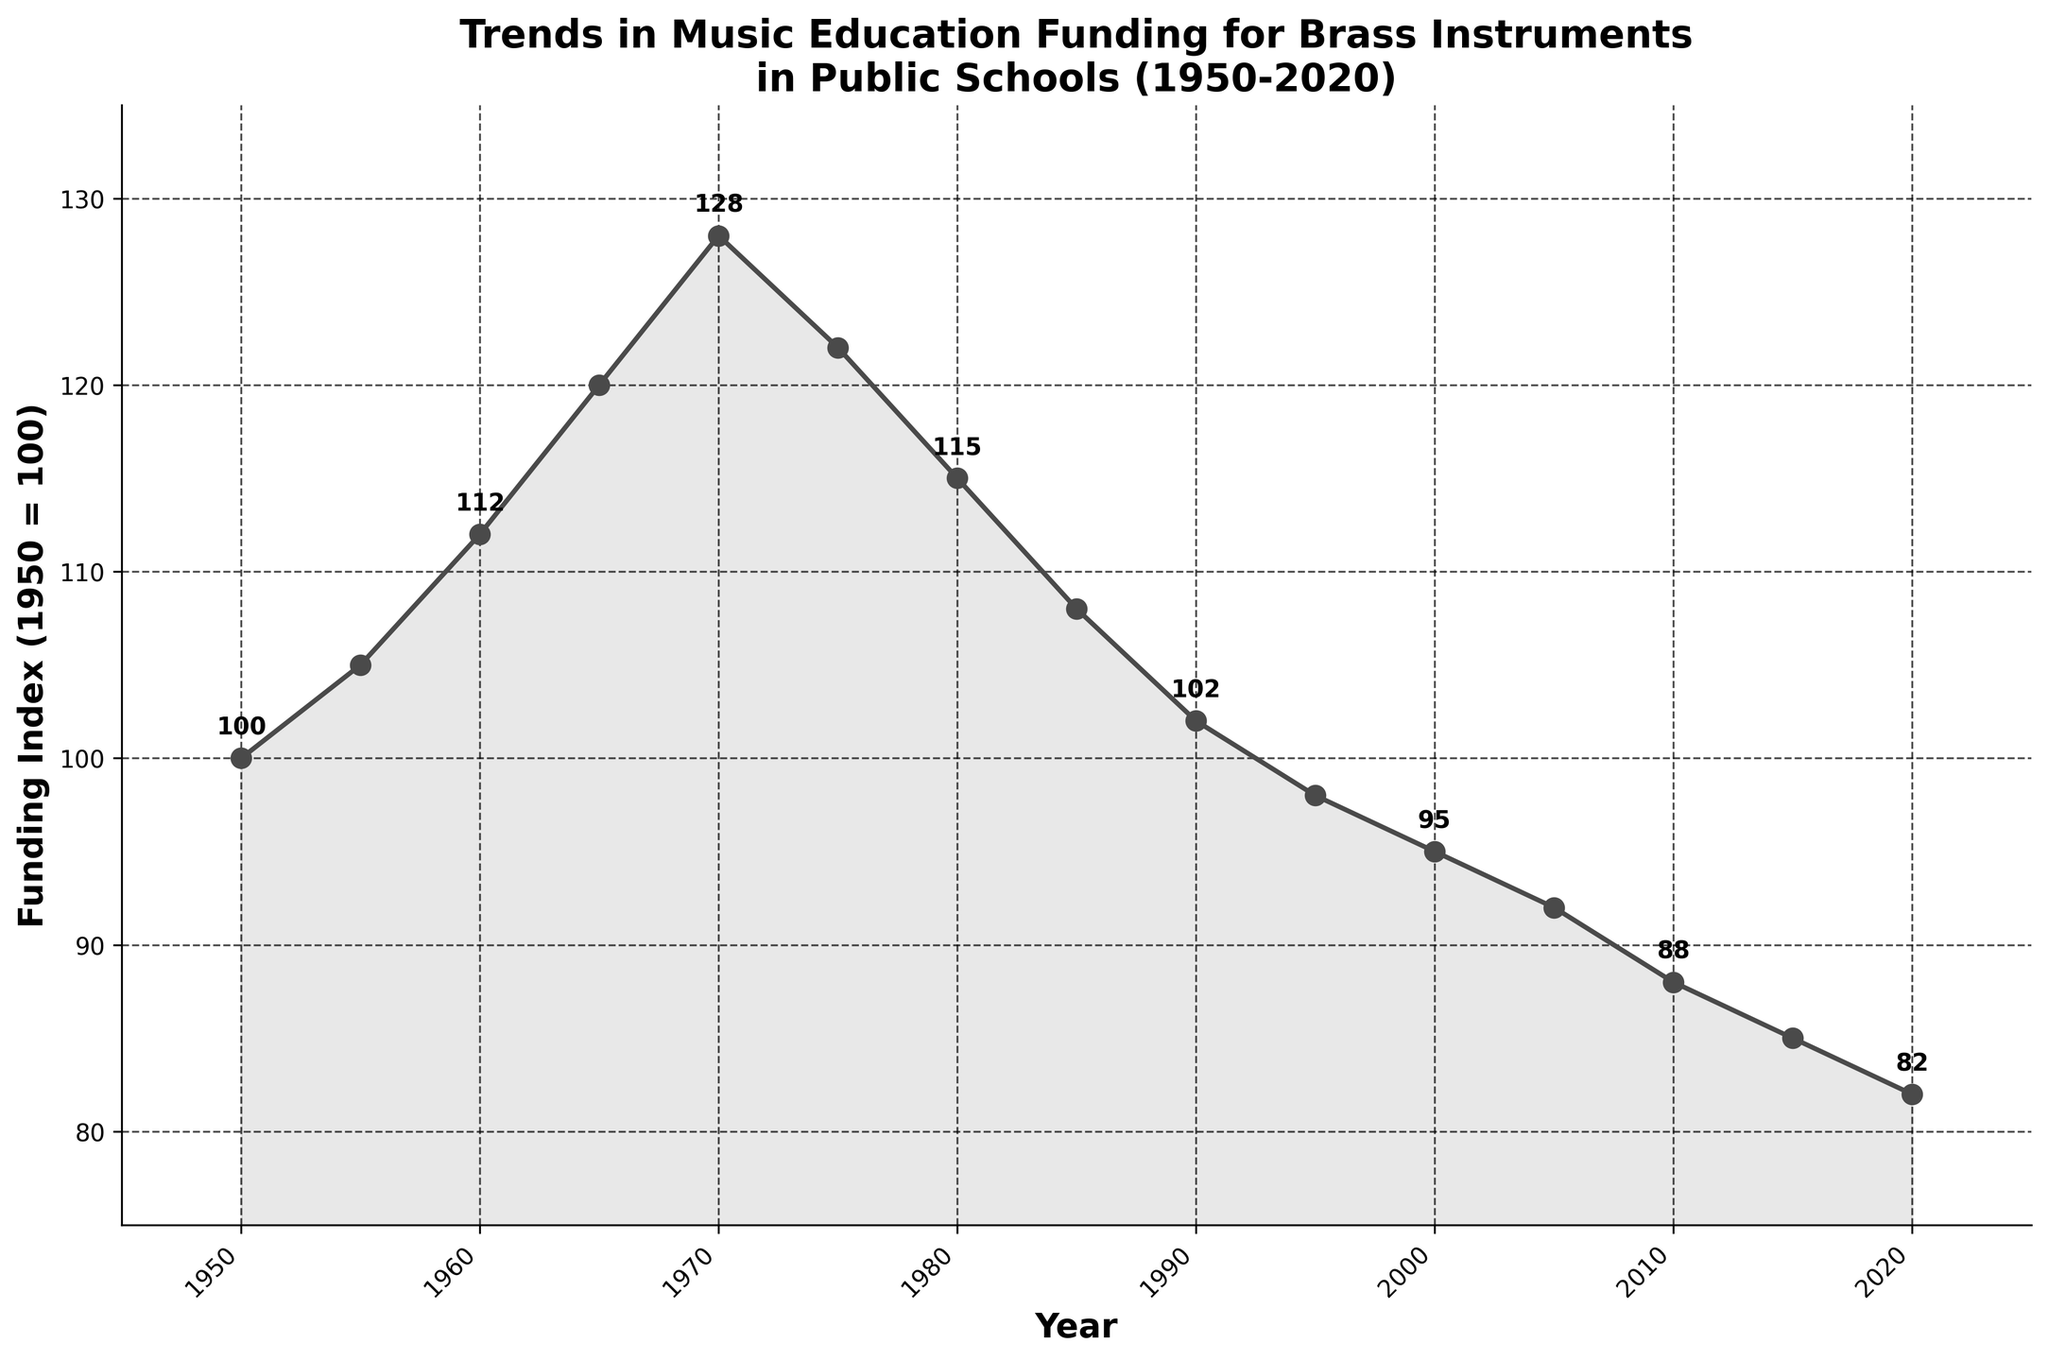What is the Funding Index value in 1970? Refer to the point on the line graph corresponding to the year 1970. The value is marked at 128.
Answer: 128 Which year had the highest Funding Index? Look for the peak of the line on the graph. The highest value is in 1970.
Answer: 1970 What is the range of the Funding Index values? Calculate the difference between the maximum and minimum values on the graph. The highest value is 128 (in 1970) and the lowest is 82 (in 2020). So, 128 - 82 = 46.
Answer: 46 How did the Funding Index change from 1975 to 1980? Find the points for 1975 and 1980 on the graph. In 1975, the value is 122, and in 1980, it is 115. The change is 122 - 115 = 7, indicating a decrease.
Answer: Decreased by 7 What is the average Funding Index over the period from 1950 to 2020? Add up all the Funding Index values and divide by the total number of years:
(100 + 105 + 112 + 120 + 128 + 122 + 115 + 108 + 102 + 98 + 95 + 92 + 88 + 85 + 82) / 15 = 1372 / 15 = 91.47
Answer: 91.47 How does the Funding Index in 2020 compare to that in 1950? Compare the values for 1950 and 2020 directly. The value in 1950 is 100, and in 2020 it is 82. So, it decreased by 100 - 82 = 18.
Answer: Decreased by 18 What general trend do you see in the Funding Index from 1950 to 2020? Observe the overall direction of the line graph. It peaks around 1970 and then shows a general decline with some fluctuations.
Answer: Initial increase, then overall decline Between which specific years did the Funding Index see the sharpest increase? Identify the steepest upward slope on the graph. The sharpest increase is seen from 1960 to 1970, where it rises from 112 to 128, an increase of 16.
Answer: 1960 to 1970 What is the median Funding Index value from 1950 to 2020? Arrange the Funding Index values in ascending order and find the middle value:
82, 85, 88, 92, 95, 98, 100, 102, 105, 108, 112, 115, 120, 122, 128
The median value is the 8th value, which is 102.
Answer: 102 